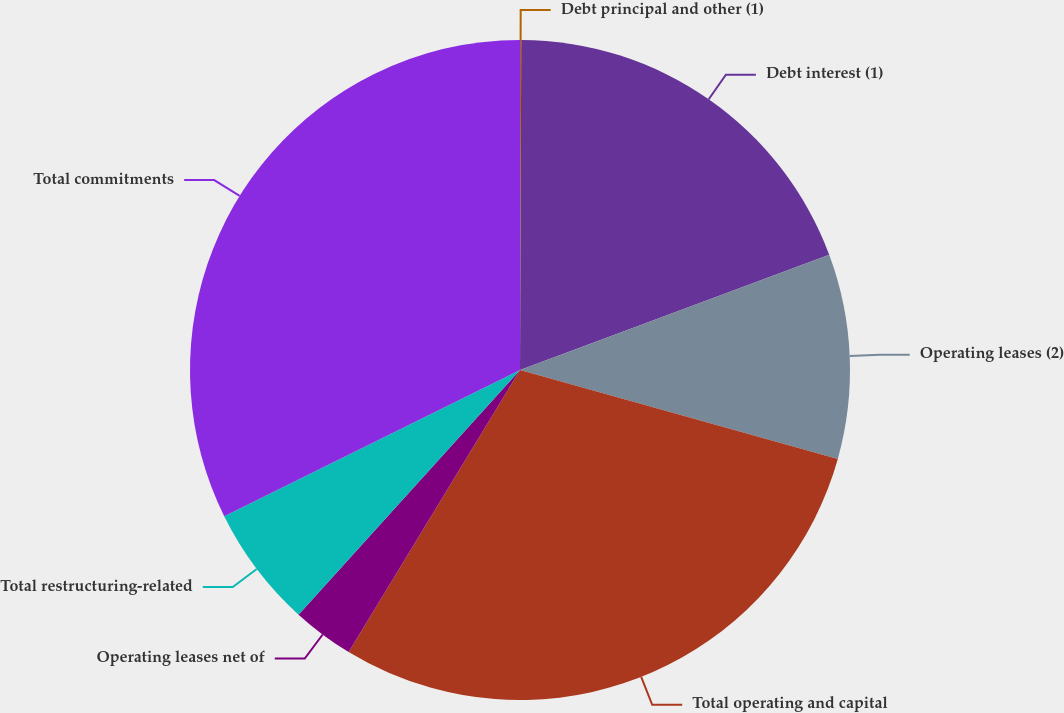Convert chart. <chart><loc_0><loc_0><loc_500><loc_500><pie_chart><fcel>Debt principal and other (1)<fcel>Debt interest (1)<fcel>Operating leases (2)<fcel>Total operating and capital<fcel>Operating leases net of<fcel>Total restructuring-related<fcel>Total commitments<nl><fcel>0.06%<fcel>19.26%<fcel>10.02%<fcel>29.35%<fcel>3.02%<fcel>5.98%<fcel>32.31%<nl></chart> 